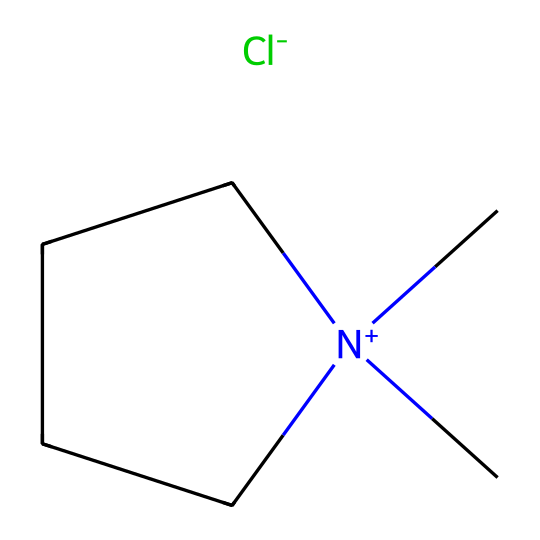What is the total number of carbon atoms in the structure? The SMILES representation indicates the presence of three carbon atoms in the side chain and one carbon atom from the ammonium group, leading to a total of five carbon atoms in the entire structure.
Answer: five How many hydrogen atoms are connected to the nitrogen? The nitrogen atom in this structure is a quaternary ammonium, and since it is bonded to three carbon groups and has no hydrogens, it has zero hydrogen atoms attached.
Answer: zero What ion is responsible for the ionic nature of this liquid? The SMILES notation indicates a chloride ion, as represented by "Cl-", which demonstrates the ionic component of the ionic liquid.
Answer: chloride What type of bonding is primarily found in this structure? The structure exhibits covalent bonding between the carbon atoms and the nitrogen atom, as well as ionic bonding between the cation and the anion (chloride).
Answer: covalent and ionic How many rings does this molecular structure contain? The representation shows a single cyclic structure defined by the "1" in the SMILES notation, signifying one ring formed between carbon atoms.
Answer: one Which part of this structure makes it suitable for food preservation? The presence of the ionic components and their low volatility allow for a non-volatile and effective medium for food preservation, minimizing spoilage reactions.
Answer: ionic components What property do room-temperature ionic liquids exhibit that is beneficial for food applications? Room-temperature ionic liquids exhibit low volatility, which is advantageous for maintaining food quality and reducing the evaporation of volatile compounds during preservation.
Answer: low volatility 